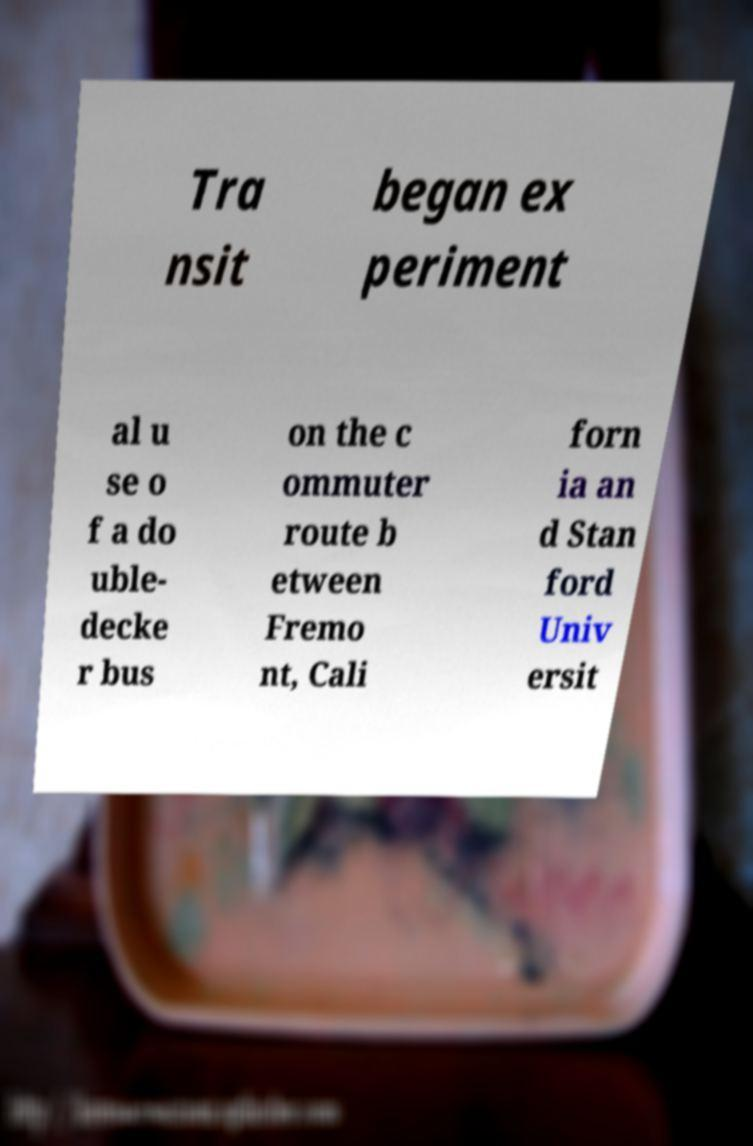Please read and relay the text visible in this image. What does it say? Tra nsit began ex periment al u se o f a do uble- decke r bus on the c ommuter route b etween Fremo nt, Cali forn ia an d Stan ford Univ ersit 